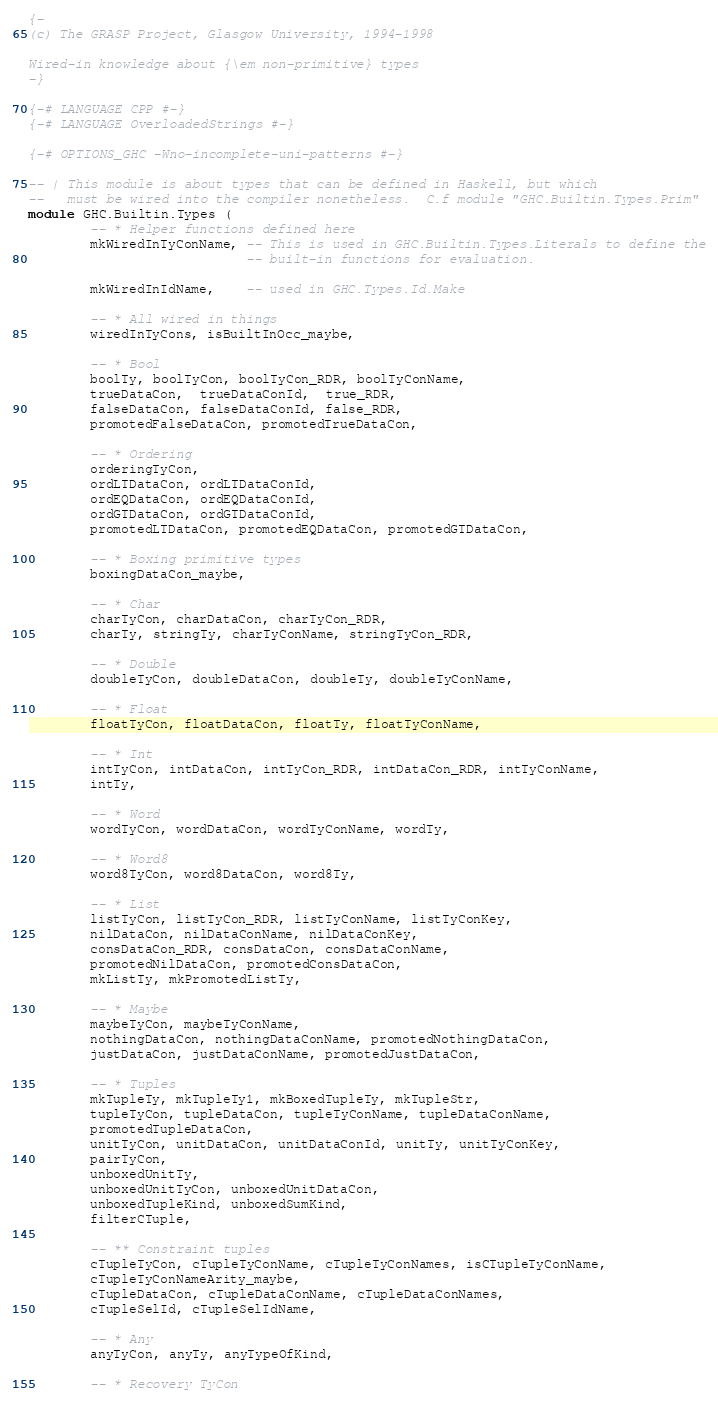<code> <loc_0><loc_0><loc_500><loc_500><_Haskell_>{-
(c) The GRASP Project, Glasgow University, 1994-1998

Wired-in knowledge about {\em non-primitive} types
-}

{-# LANGUAGE CPP #-}
{-# LANGUAGE OverloadedStrings #-}

{-# OPTIONS_GHC -Wno-incomplete-uni-patterns #-}

-- | This module is about types that can be defined in Haskell, but which
--   must be wired into the compiler nonetheless.  C.f module "GHC.Builtin.Types.Prim"
module GHC.Builtin.Types (
        -- * Helper functions defined here
        mkWiredInTyConName, -- This is used in GHC.Builtin.Types.Literals to define the
                            -- built-in functions for evaluation.

        mkWiredInIdName,    -- used in GHC.Types.Id.Make

        -- * All wired in things
        wiredInTyCons, isBuiltInOcc_maybe,

        -- * Bool
        boolTy, boolTyCon, boolTyCon_RDR, boolTyConName,
        trueDataCon,  trueDataConId,  true_RDR,
        falseDataCon, falseDataConId, false_RDR,
        promotedFalseDataCon, promotedTrueDataCon,

        -- * Ordering
        orderingTyCon,
        ordLTDataCon, ordLTDataConId,
        ordEQDataCon, ordEQDataConId,
        ordGTDataCon, ordGTDataConId,
        promotedLTDataCon, promotedEQDataCon, promotedGTDataCon,

        -- * Boxing primitive types
        boxingDataCon_maybe,

        -- * Char
        charTyCon, charDataCon, charTyCon_RDR,
        charTy, stringTy, charTyConName, stringTyCon_RDR,

        -- * Double
        doubleTyCon, doubleDataCon, doubleTy, doubleTyConName,

        -- * Float
        floatTyCon, floatDataCon, floatTy, floatTyConName,

        -- * Int
        intTyCon, intDataCon, intTyCon_RDR, intDataCon_RDR, intTyConName,
        intTy,

        -- * Word
        wordTyCon, wordDataCon, wordTyConName, wordTy,

        -- * Word8
        word8TyCon, word8DataCon, word8Ty,

        -- * List
        listTyCon, listTyCon_RDR, listTyConName, listTyConKey,
        nilDataCon, nilDataConName, nilDataConKey,
        consDataCon_RDR, consDataCon, consDataConName,
        promotedNilDataCon, promotedConsDataCon,
        mkListTy, mkPromotedListTy,

        -- * Maybe
        maybeTyCon, maybeTyConName,
        nothingDataCon, nothingDataConName, promotedNothingDataCon,
        justDataCon, justDataConName, promotedJustDataCon,

        -- * Tuples
        mkTupleTy, mkTupleTy1, mkBoxedTupleTy, mkTupleStr,
        tupleTyCon, tupleDataCon, tupleTyConName, tupleDataConName,
        promotedTupleDataCon,
        unitTyCon, unitDataCon, unitDataConId, unitTy, unitTyConKey,
        pairTyCon,
        unboxedUnitTy,
        unboxedUnitTyCon, unboxedUnitDataCon,
        unboxedTupleKind, unboxedSumKind,
        filterCTuple,

        -- ** Constraint tuples
        cTupleTyCon, cTupleTyConName, cTupleTyConNames, isCTupleTyConName,
        cTupleTyConNameArity_maybe,
        cTupleDataCon, cTupleDataConName, cTupleDataConNames,
        cTupleSelId, cTupleSelIdName,

        -- * Any
        anyTyCon, anyTy, anyTypeOfKind,

        -- * Recovery TyCon</code> 